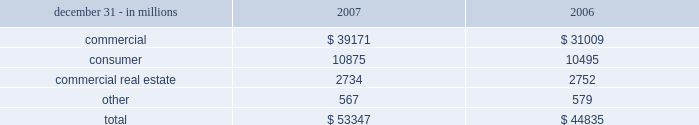Net unfunded credit commitments .
Commitments to extend credit represent arrangements to lend funds subject to specified contractual conditions .
At december 31 , 2007 , commercial commitments are reported net of $ 8.9 billion of participations , assignments and syndications , primarily to financial services companies .
The comparable amount at december 31 , 2006 was $ 8.3 billion .
Commitments generally have fixed expiration dates , may require payment of a fee , and contain termination clauses in the event the customer 2019s credit quality deteriorates .
Based on our historical experience , most commitments expire unfunded , and therefore cash requirements are substantially less than the total commitment .
Consumer home equity lines of credit accounted for 80% ( 80 % ) of consumer unfunded credit commitments .
Unfunded credit commitments related to market street totaled $ 8.8 billion at december 31 , 2007 and $ 5.6 billion at december 31 , 2006 and are included in the preceding table primarily within the 201ccommercial 201d and 201cconsumer 201d categories .
Note 24 commitments and guarantees includes information regarding standby letters of credit and bankers 2019 acceptances .
At december 31 , 2007 , the largest industry concentration was for general medical and surgical hospitals , which accounted for approximately 5% ( 5 % ) of the total letters of credit and bankers 2019 acceptances .
At december 31 , 2007 , we pledged $ 1.6 billion of loans to the federal reserve bank ( 201cfrb 201d ) and $ 33.5 billion of loans to the federal home loan bank ( 201cfhlb 201d ) as collateral for the contingent ability to borrow , if necessary .
Certain directors and executive officers of pnc and its subsidiaries , as well as certain affiliated companies of these directors and officers , were customers of and had loans with subsidiary banks in the ordinary course of business .
All such loans were on substantially the same terms , including interest rates and collateral , as those prevailing at the time for comparable transactions with other customers and did not involve more than a normal risk of collectibility or present other unfavorable features .
The aggregate principal amounts of these loans were $ 13 million at december 31 , 2007 and $ 18 million at december 31 , 2006 .
During 2007 , new loans of $ 48 million were funded and repayments totaled $ 53 million. .
Consumer home equity lines of credit accounted for 80% ( 80 % ) of consumer unfunded credit commitments . what is this amount in 2007 in millions of dollars? 
Computations: (80% * 10875)
Answer: 8700.0. 